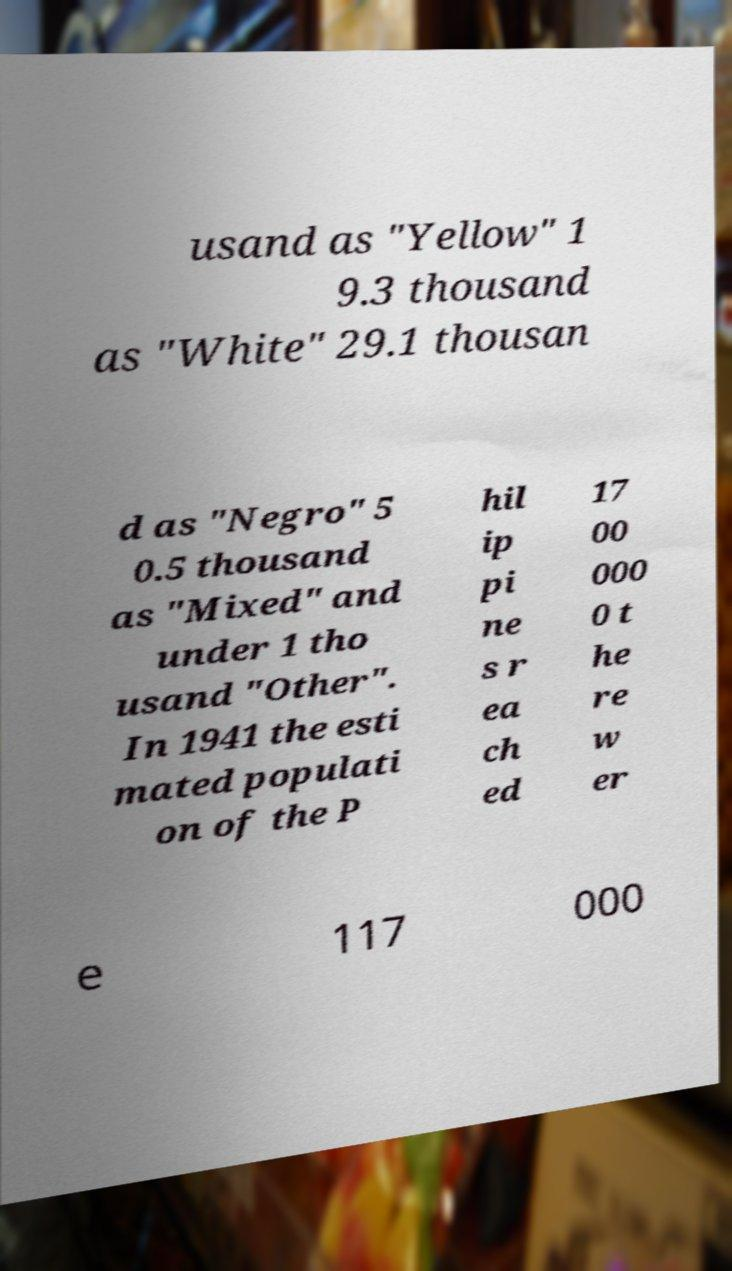Please identify and transcribe the text found in this image. usand as "Yellow" 1 9.3 thousand as "White" 29.1 thousan d as "Negro" 5 0.5 thousand as "Mixed" and under 1 tho usand "Other". In 1941 the esti mated populati on of the P hil ip pi ne s r ea ch ed 17 00 000 0 t he re w er e 117 000 